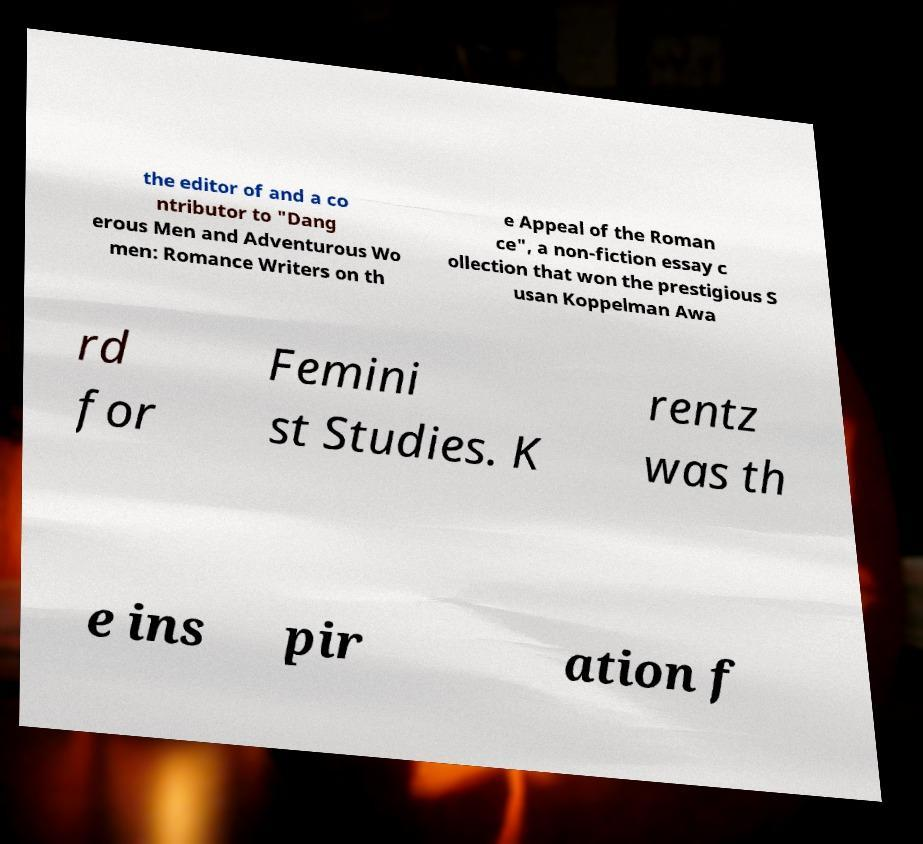Please read and relay the text visible in this image. What does it say? the editor of and a co ntributor to "Dang erous Men and Adventurous Wo men: Romance Writers on th e Appeal of the Roman ce", a non-fiction essay c ollection that won the prestigious S usan Koppelman Awa rd for Femini st Studies. K rentz was th e ins pir ation f 